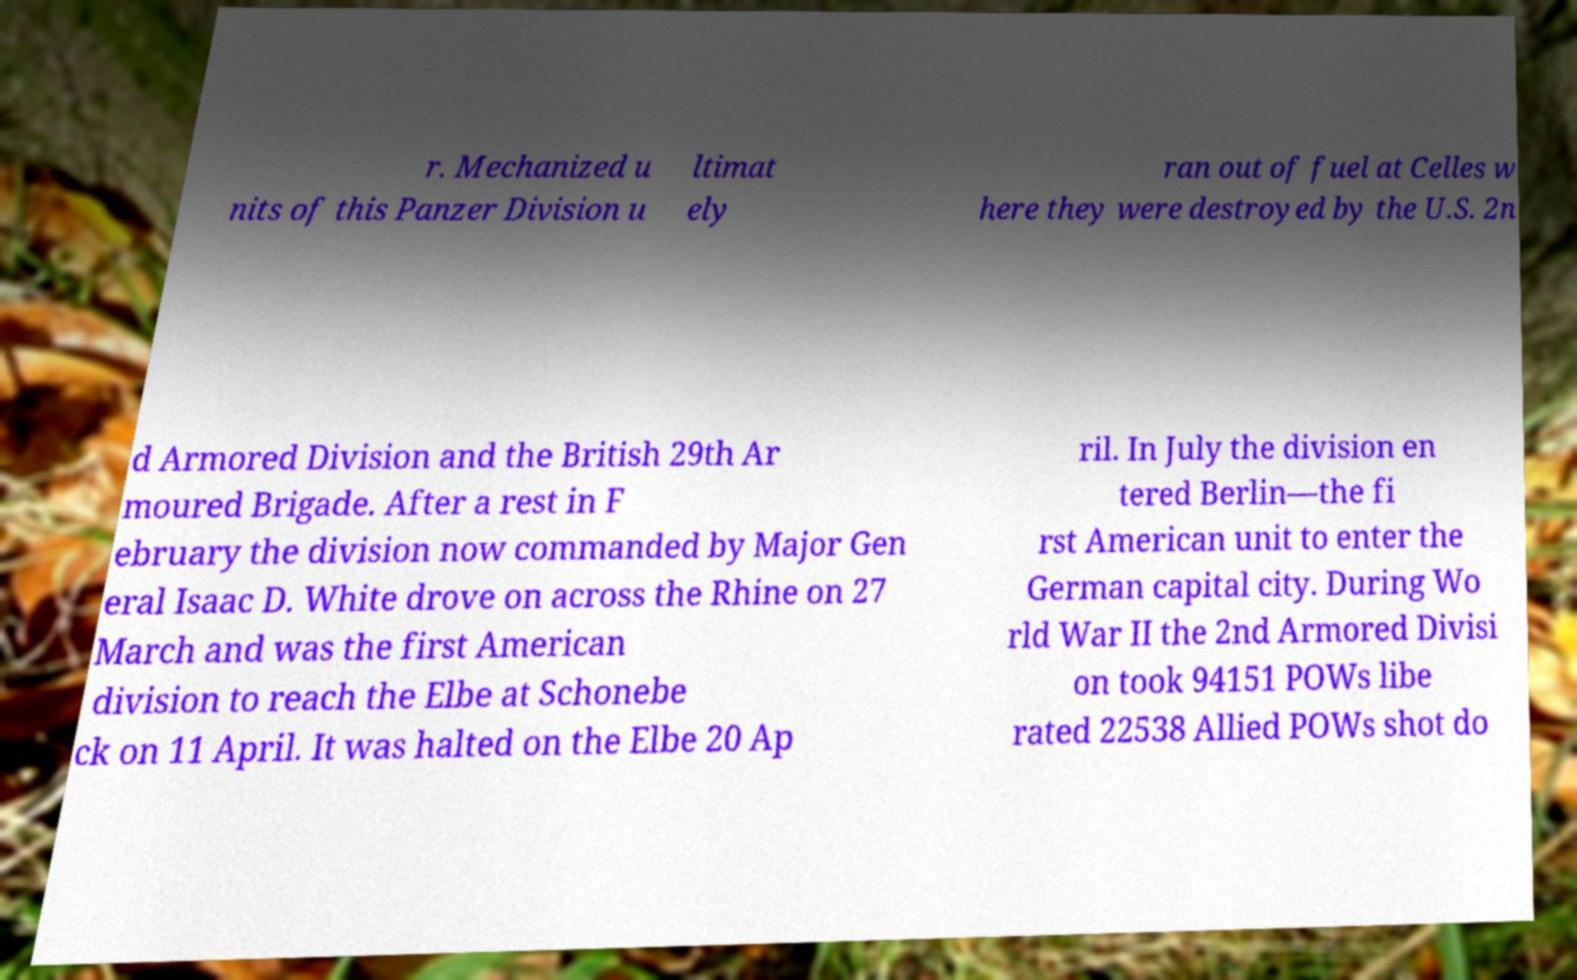There's text embedded in this image that I need extracted. Can you transcribe it verbatim? r. Mechanized u nits of this Panzer Division u ltimat ely ran out of fuel at Celles w here they were destroyed by the U.S. 2n d Armored Division and the British 29th Ar moured Brigade. After a rest in F ebruary the division now commanded by Major Gen eral Isaac D. White drove on across the Rhine on 27 March and was the first American division to reach the Elbe at Schonebe ck on 11 April. It was halted on the Elbe 20 Ap ril. In July the division en tered Berlin—the fi rst American unit to enter the German capital city. During Wo rld War II the 2nd Armored Divisi on took 94151 POWs libe rated 22538 Allied POWs shot do 